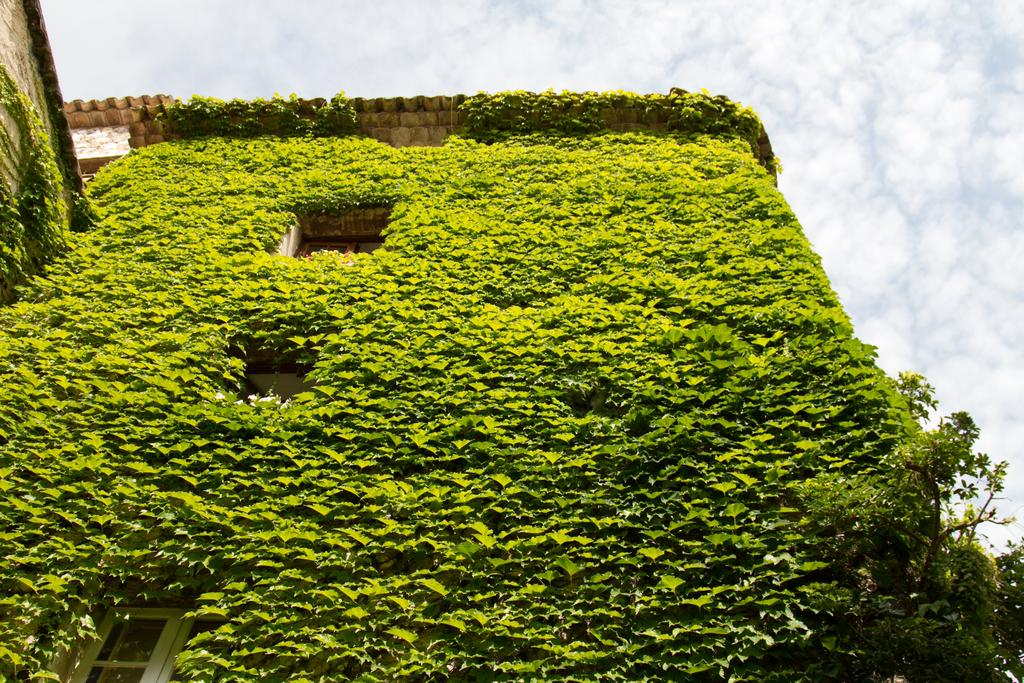What is covering the house in the image? There are leaves on a house in the image. How would you describe the sky in the image? The sky is cloudy in the image. What type of lace is draped over the house in the image? There is no lace present in the image; it features leaves on a house. What event is taking place in the image? There is no event depicted in the image; it simply shows a house with leaves on it and a cloudy sky. 